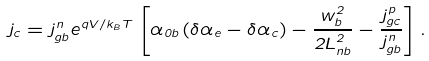Convert formula to latex. <formula><loc_0><loc_0><loc_500><loc_500>j _ { c } = j _ { g b } ^ { n } e ^ { q V / k _ { B } T } \left [ \alpha _ { 0 b } \left ( \delta \alpha _ { e } - \delta \alpha _ { c } \right ) - \frac { w _ { b } ^ { 2 } } { 2 L _ { n b } ^ { 2 } } - \frac { j ^ { p } _ { g c } } { j ^ { n } _ { g b } } \right ] .</formula> 